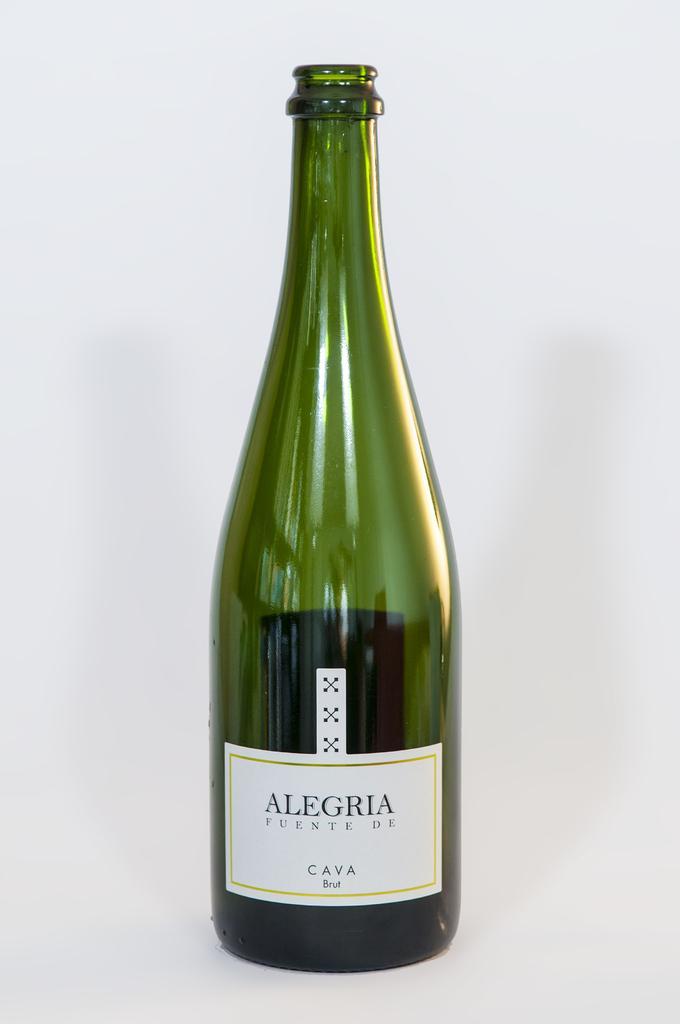How would you summarize this image in a sentence or two? This green color bottle is highlighted in this picture. 